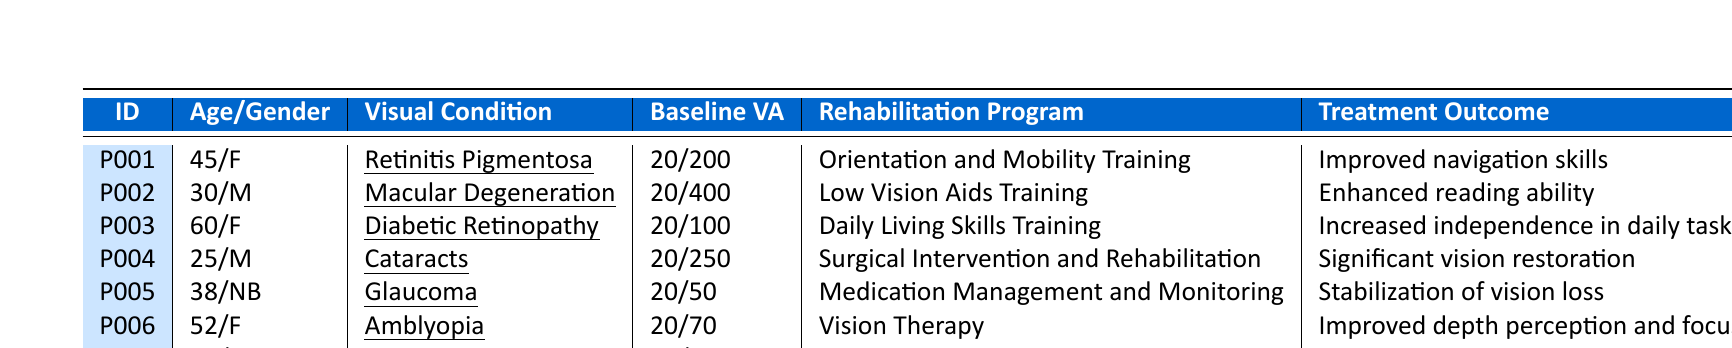What is the oldest patient in the table? The oldest patient in the data is P007, who is 72 years old.
Answer: 72 How many patients had a baseline visual acuity of 20/400? There are 2 patients with a baseline visual acuity of 20/400: P002 and P007.
Answer: 2 Which visual condition shows the treatment outcome of "Enhanced reading ability"? The visual condition that shows this outcome is Macular Degeneration, corresponding to patient P002.
Answer: Macular Degeneration What is the average age of patients who underwent the Orientation and Mobility Training program? The patients who underwent this program are P001. Since there is only one patient, the average age is 45 years old.
Answer: 45 Did any patient have "Significant vision restoration" as the treatment outcome? Yes, patient P004 had "Significant vision restoration" as the treatment outcome.
Answer: Yes Which rehabilitation program had the least follow-up duration? The rehabilitation program with the least follow-up duration is "Surgical Intervention and Rehabilitation", associated with patient P004, which lasted for 3 months.
Answer: Surgical Intervention and Rehabilitation What percentage of patients with Glaucoma had improved treatment outcomes? The only patient with Glaucoma (P005) had a treatment outcome of "Stabilization of vision loss," which is not an improvement. Therefore, the percentage of improved outcomes for Glaucoma patients is 0%.
Answer: 0% List all patients who had an improvement in their treatment outcome. The patients who had improvements are P001 (Improved navigation skills), P002 (Enhanced reading ability), P003 (Increased independence in daily tasks), P004 (Significant vision restoration), P006 (Improved depth perception and focus), and P007 (Partial restoration of vision).
Answer: P001, P002, P003, P004, P006, P007 How many males are in the table? There are 3 male patients: P002, P004, and P007.
Answer: 3 What is the follow-up duration for the patient with Amblyopia? The follow-up duration for the patient with Amblyopia (P006) is 5 months.
Answer: 5 months 